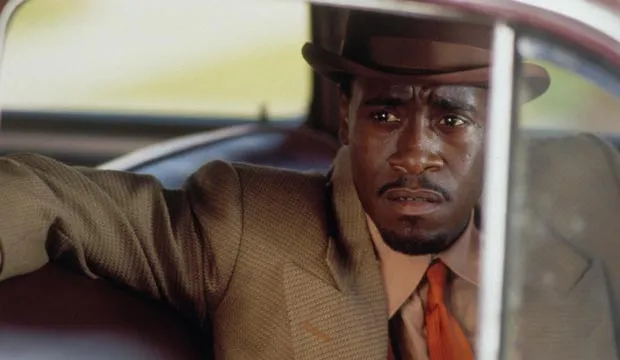Can you describe the surroundings this character might be in? The character, seated in an older model car, gives the impression that he is in a city setting from a bygone era. The car’s interior, with its vintage appearance, suggests that the scene takes place in the mid-20th century. Outside the car window, we might imagine bustling city streets filled with people in similar period attire, old-fashioned storefronts, and perhaps even a smoky atmosphere typical of noir films. 